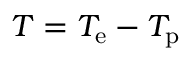Convert formula to latex. <formula><loc_0><loc_0><loc_500><loc_500>T = T _ { e } - T _ { p }</formula> 